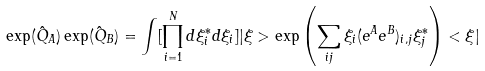Convert formula to latex. <formula><loc_0><loc_0><loc_500><loc_500>\exp ( \hat { Q } _ { A } ) \exp ( \hat { Q } _ { B } ) = \int [ \prod _ { i = 1 } ^ { N } d \xi ^ { * } _ { i } d \xi _ { i } ] | \xi > \exp \left ( \sum _ { i j } \xi _ { i } ( e ^ { A } e ^ { B } ) _ { i , j } \xi ^ { * } _ { j } \right ) < \xi |</formula> 